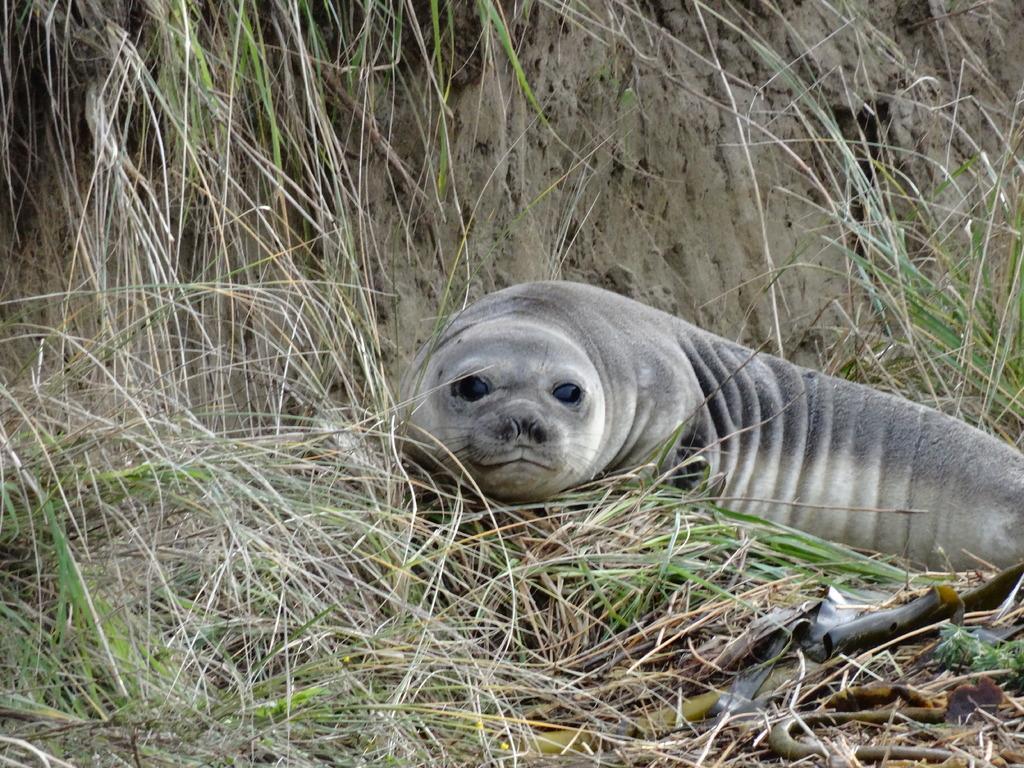Can you describe this image briefly? In this picture I can see there is a seal and there's grass on the floor. In the backdrop there is a mountain and there is soil. 